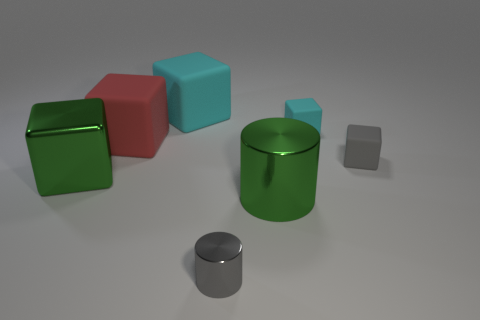Subtract 2 blocks. How many blocks are left? 3 Subtract all large green cubes. How many cubes are left? 4 Subtract all green cubes. How many cubes are left? 4 Subtract all yellow blocks. Subtract all green cylinders. How many blocks are left? 5 Add 1 large rubber cubes. How many objects exist? 8 Subtract all cubes. How many objects are left? 2 Subtract 0 red spheres. How many objects are left? 7 Subtract all large brown shiny spheres. Subtract all cyan rubber objects. How many objects are left? 5 Add 5 tiny gray rubber things. How many tiny gray rubber things are left? 6 Add 3 big cylinders. How many big cylinders exist? 4 